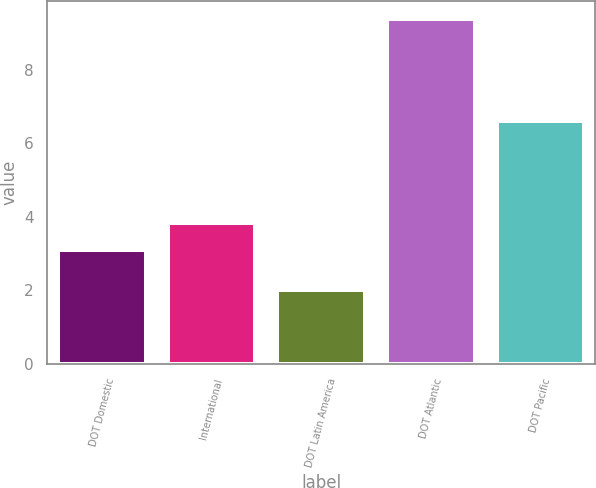Convert chart to OTSL. <chart><loc_0><loc_0><loc_500><loc_500><bar_chart><fcel>DOT Domestic<fcel>International<fcel>DOT Latin America<fcel>DOT Atlantic<fcel>DOT Pacific<nl><fcel>3.1<fcel>3.84<fcel>2<fcel>9.4<fcel>6.6<nl></chart> 